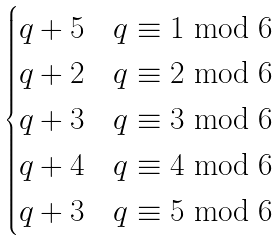Convert formula to latex. <formula><loc_0><loc_0><loc_500><loc_500>\begin{cases} q + 5 & q \equiv 1 \bmod 6 \\ q + 2 & q \equiv 2 \bmod 6 \\ q + 3 & q \equiv 3 \bmod 6 \\ q + 4 & q \equiv 4 \bmod 6 \\ q + 3 & q \equiv 5 \bmod 6 \end{cases}</formula> 